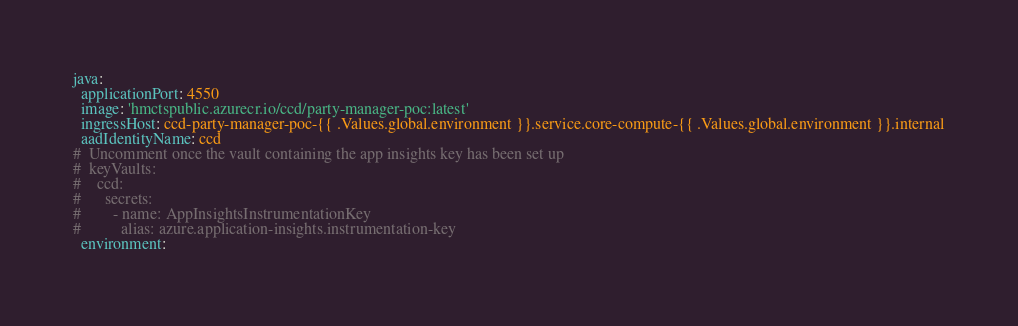<code> <loc_0><loc_0><loc_500><loc_500><_YAML_>java:
  applicationPort: 4550
  image: 'hmctspublic.azurecr.io/ccd/party-manager-poc:latest'
  ingressHost: ccd-party-manager-poc-{{ .Values.global.environment }}.service.core-compute-{{ .Values.global.environment }}.internal
  aadIdentityName: ccd
#  Uncomment once the vault containing the app insights key has been set up
#  keyVaults:
#    ccd:
#      secrets:
#        - name: AppInsightsInstrumentationKey
#          alias: azure.application-insights.instrumentation-key
  environment:
</code> 